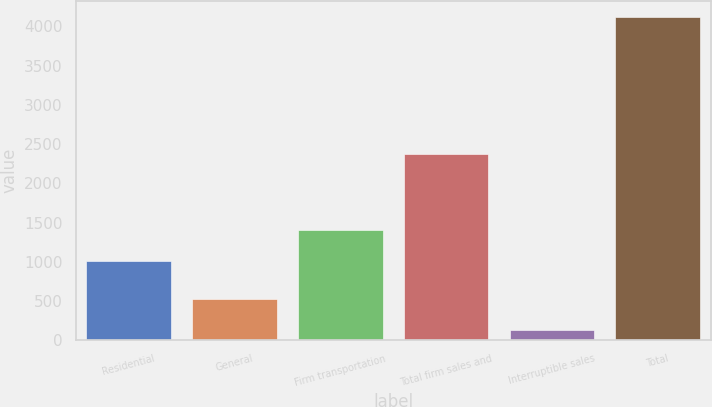Convert chart to OTSL. <chart><loc_0><loc_0><loc_500><loc_500><bar_chart><fcel>Residential<fcel>General<fcel>Firm transportation<fcel>Total firm sales and<fcel>Interruptible sales<fcel>Total<nl><fcel>1010<fcel>526.5<fcel>1409.5<fcel>2374<fcel>127<fcel>4122<nl></chart> 